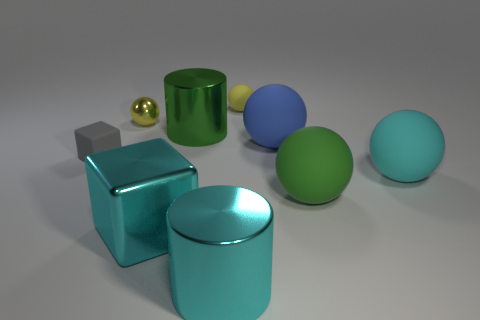Can you describe the colors of the objects in the image? Certainly! The objects in the image include a large cyan ball, a small gold sphere, a yellow matte cylinder, a blue sphere, a green sphere, a teal cylinder, and a silver cube. 